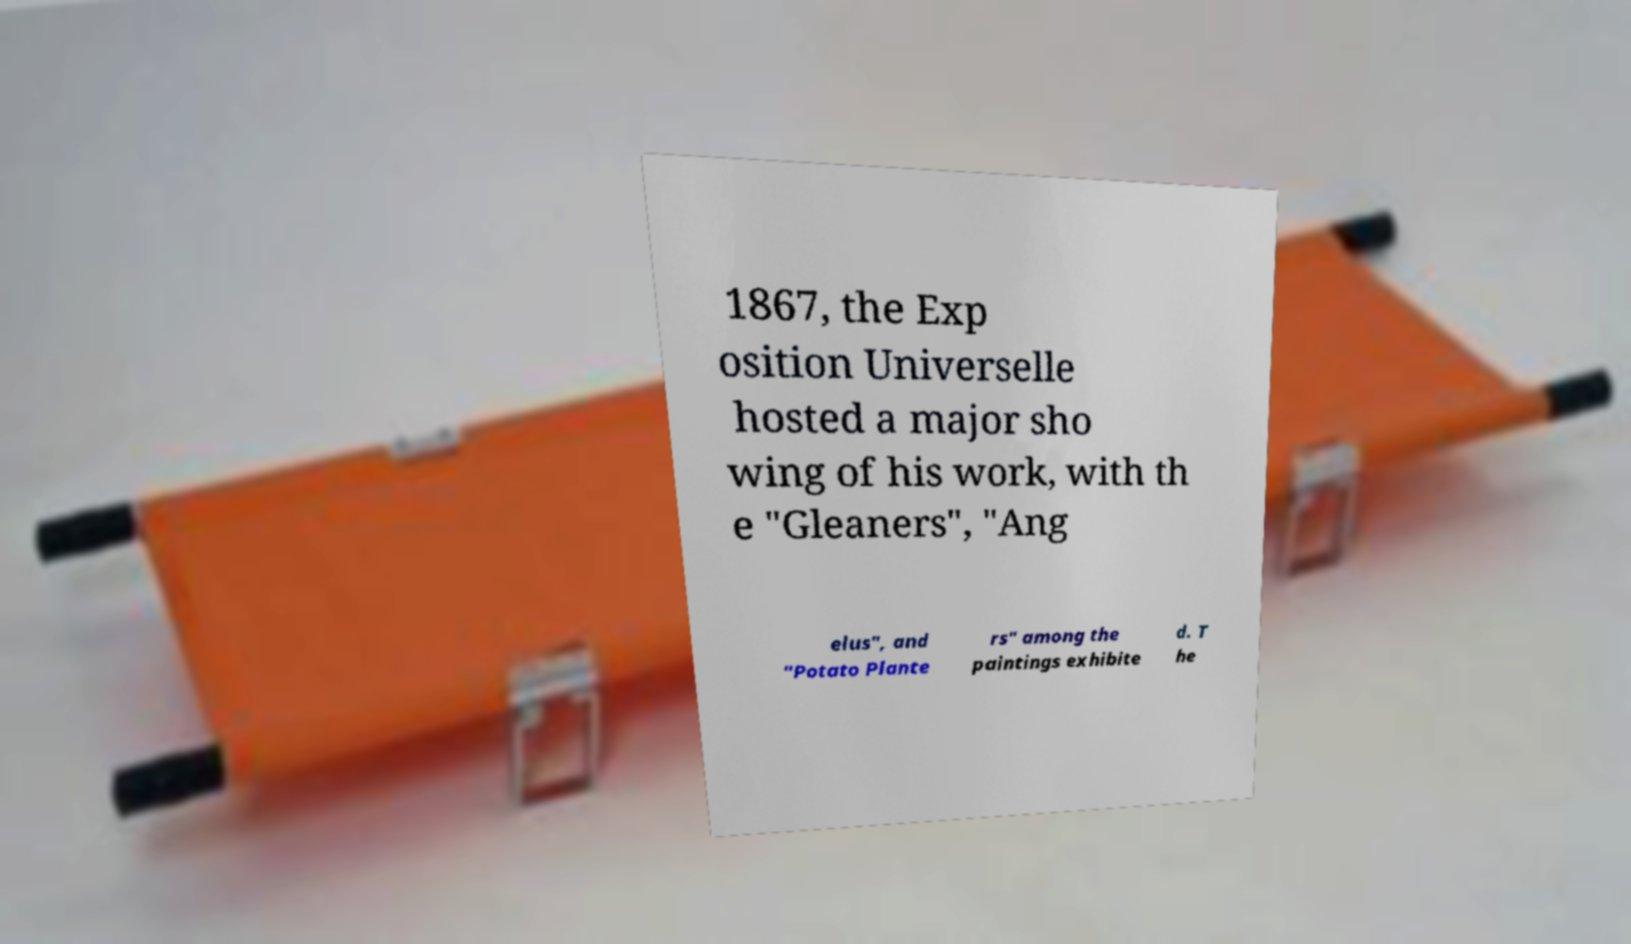I need the written content from this picture converted into text. Can you do that? 1867, the Exp osition Universelle hosted a major sho wing of his work, with th e "Gleaners", "Ang elus", and "Potato Plante rs" among the paintings exhibite d. T he 